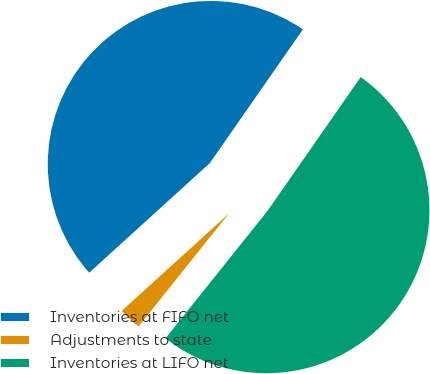Convert chart. <chart><loc_0><loc_0><loc_500><loc_500><pie_chart><fcel>Inventories at FIFO net<fcel>Adjustments to state<fcel>Inventories at LIFO net<nl><fcel>46.42%<fcel>2.52%<fcel>51.06%<nl></chart> 